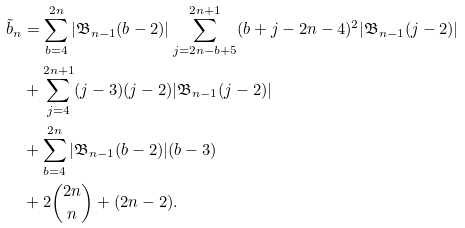Convert formula to latex. <formula><loc_0><loc_0><loc_500><loc_500>\tilde { b } _ { n } & = \sum _ { b = 4 } ^ { 2 n } | \mathfrak { B } _ { n - 1 } ( b - 2 ) | \sum _ { j = 2 n - b + 5 } ^ { 2 n + 1 } ( b + j - 2 n - 4 ) ^ { 2 } | \mathfrak { B } _ { n - 1 } ( j - 2 ) | \\ & + \sum _ { j = 4 } ^ { 2 n + 1 } ( j - 3 ) ( j - 2 ) | \mathfrak { B } _ { n - 1 } ( j - 2 ) | \\ & + \sum _ { b = 4 } ^ { 2 n } | \mathfrak { B } _ { n - 1 } ( b - 2 ) | ( b - 3 ) \\ & + 2 \binom { 2 n } { n } + ( 2 n - 2 ) .</formula> 